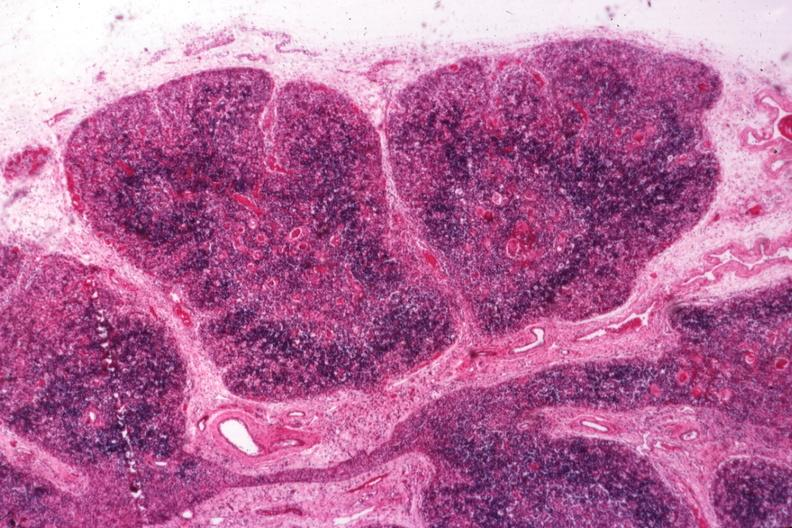s thymus present?
Answer the question using a single word or phrase. Yes 